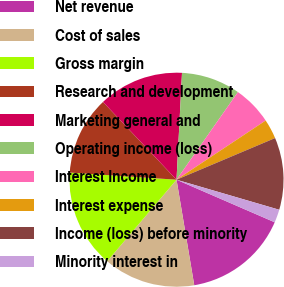Convert chart to OTSL. <chart><loc_0><loc_0><loc_500><loc_500><pie_chart><fcel>Net revenue<fcel>Cost of sales<fcel>Gross margin<fcel>Research and development<fcel>Marketing general and<fcel>Operating income (loss)<fcel>Interest Income<fcel>Interest expense<fcel>Income (loss) before minority<fcel>Minority interest in<nl><fcel>15.84%<fcel>13.86%<fcel>14.85%<fcel>11.88%<fcel>12.87%<fcel>8.91%<fcel>5.94%<fcel>2.97%<fcel>10.89%<fcel>1.98%<nl></chart> 